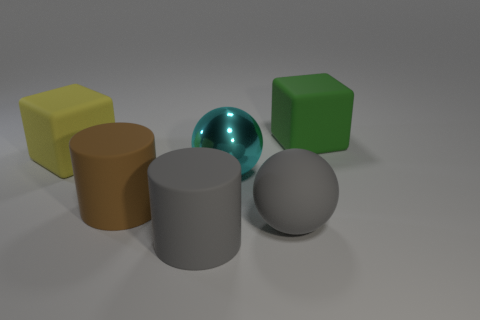Subtract all blue cylinders. Subtract all cyan cubes. How many cylinders are left? 2 Subtract all red cubes. How many brown spheres are left? 0 Add 6 big yellows. How many big things exist? 0 Subtract all large metallic things. Subtract all large gray things. How many objects are left? 3 Add 2 large cyan balls. How many large cyan balls are left? 3 Add 1 green things. How many green things exist? 2 Add 1 large green blocks. How many objects exist? 7 Subtract all gray spheres. How many spheres are left? 1 Subtract 0 brown cubes. How many objects are left? 6 Subtract all cylinders. How many objects are left? 4 